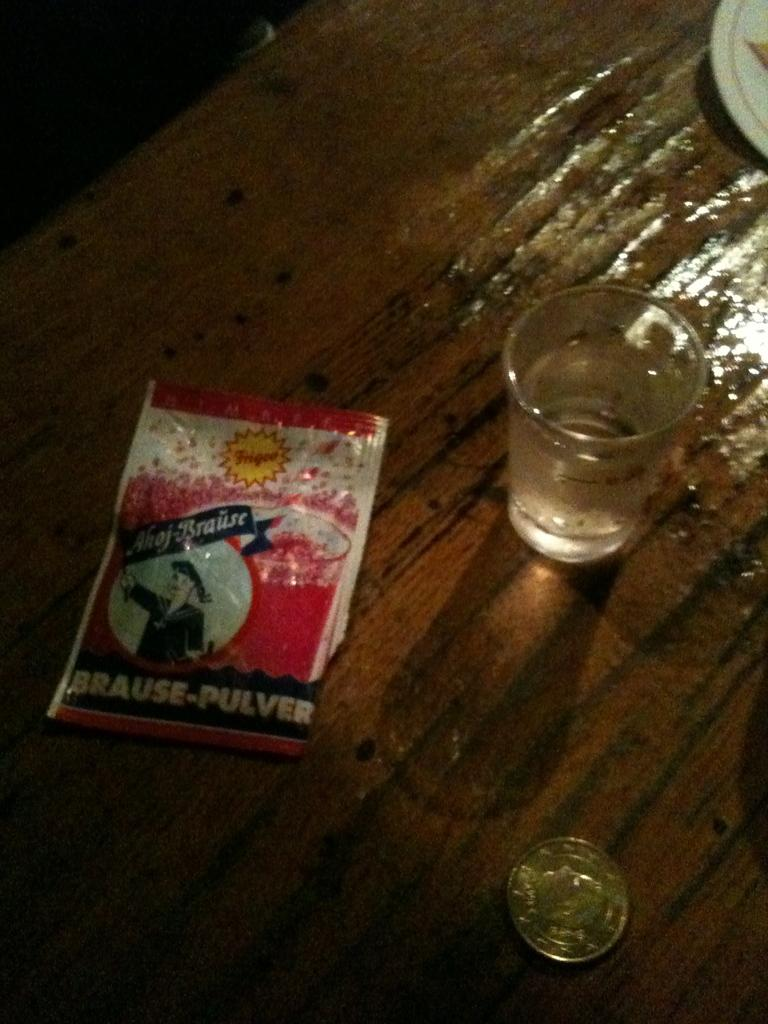Provide a one-sentence caption for the provided image. A shot glass and a coin are next to a drink mix package saying brause-pulver. 